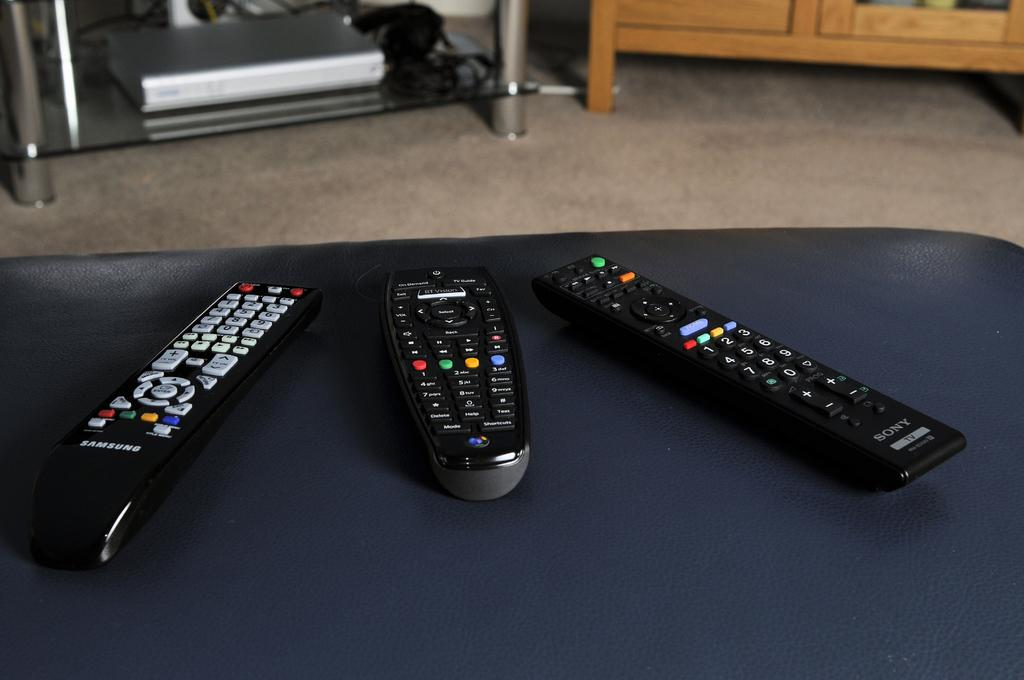<image>
Share a concise interpretation of the image provided. A Sony remote control sitting on a table with two other remote controls. 